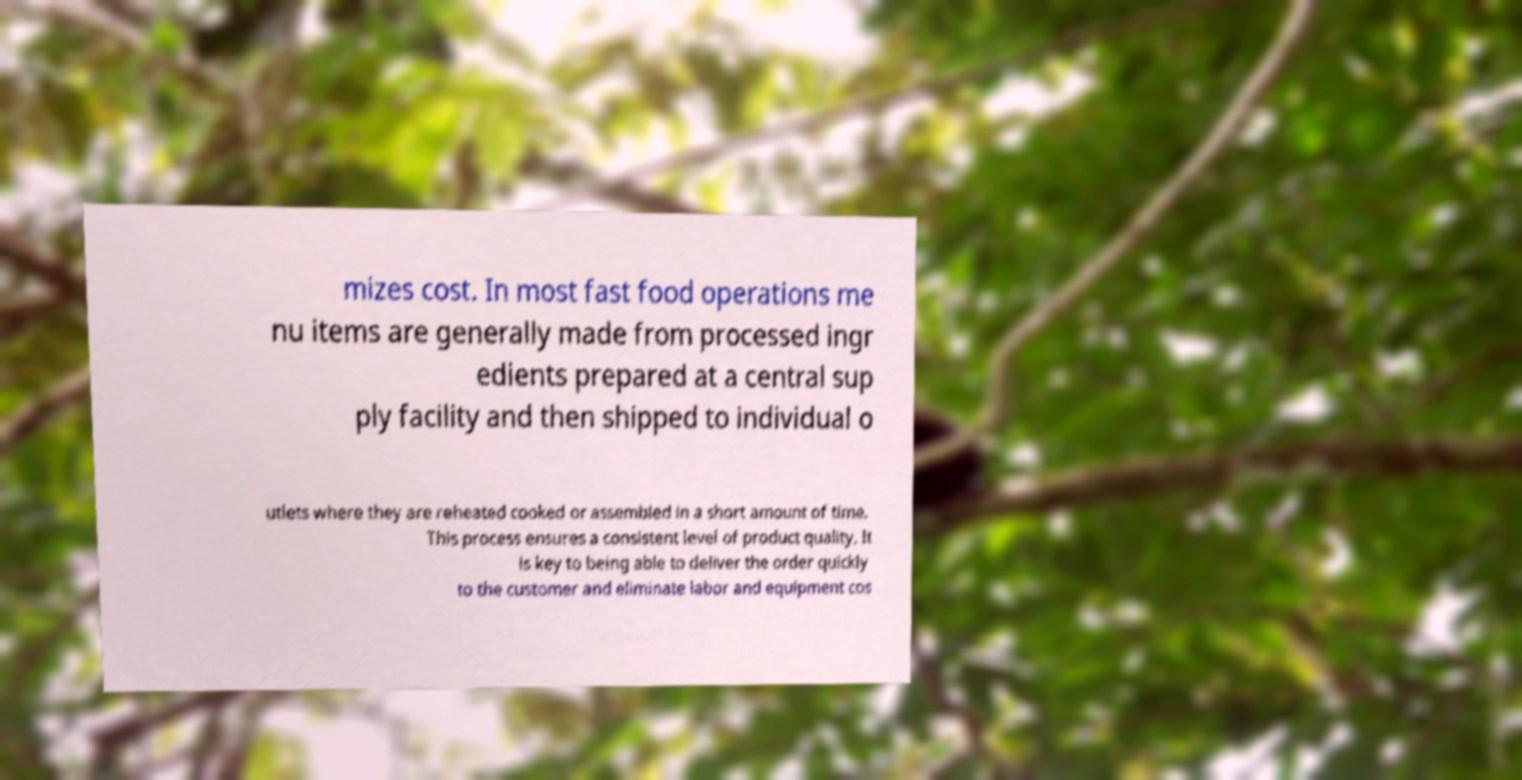For documentation purposes, I need the text within this image transcribed. Could you provide that? mizes cost. In most fast food operations me nu items are generally made from processed ingr edients prepared at a central sup ply facility and then shipped to individual o utlets where they are reheated cooked or assembled in a short amount of time. This process ensures a consistent level of product quality. It is key to being able to deliver the order quickly to the customer and eliminate labor and equipment cos 